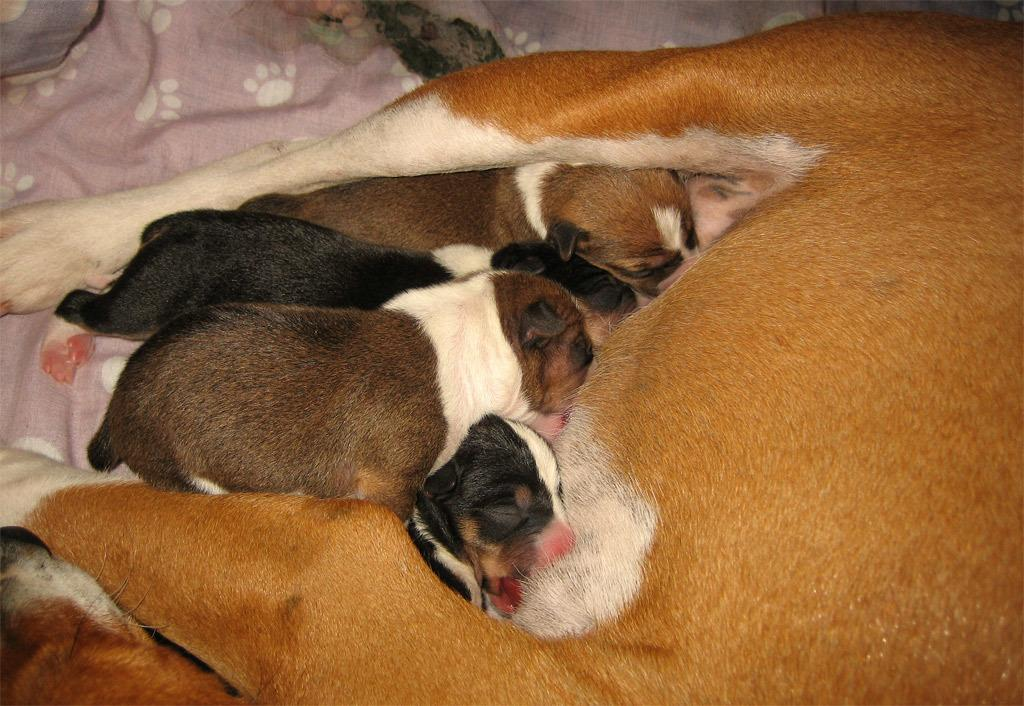What type of animals are in the image? There are dogs in the image. Can you describe the colors of the dogs? The dogs are in brown, white, black, and cream colors. What is in the background of the image? There is a cloth in the background of the image. What color is the cloth? The cloth is in a light pink color. What type of joke is being told by the dogs in the image? There is no indication in the image that the dogs are telling a joke, as they are simply depicted in their respective colors. 